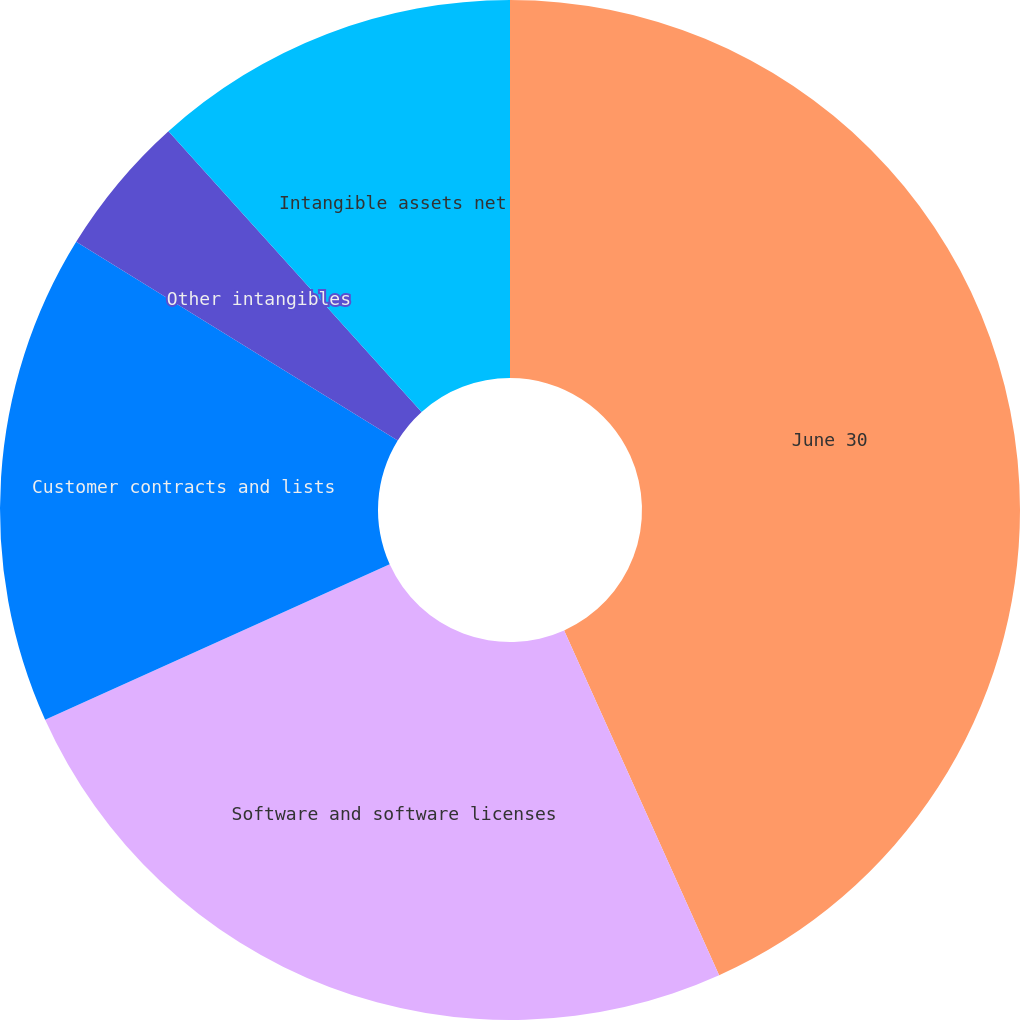Convert chart to OTSL. <chart><loc_0><loc_0><loc_500><loc_500><pie_chart><fcel>June 30<fcel>Software and software licenses<fcel>Customer contracts and lists<fcel>Other intangibles<fcel>Intangible assets net<nl><fcel>43.28%<fcel>24.98%<fcel>15.56%<fcel>4.51%<fcel>11.68%<nl></chart> 